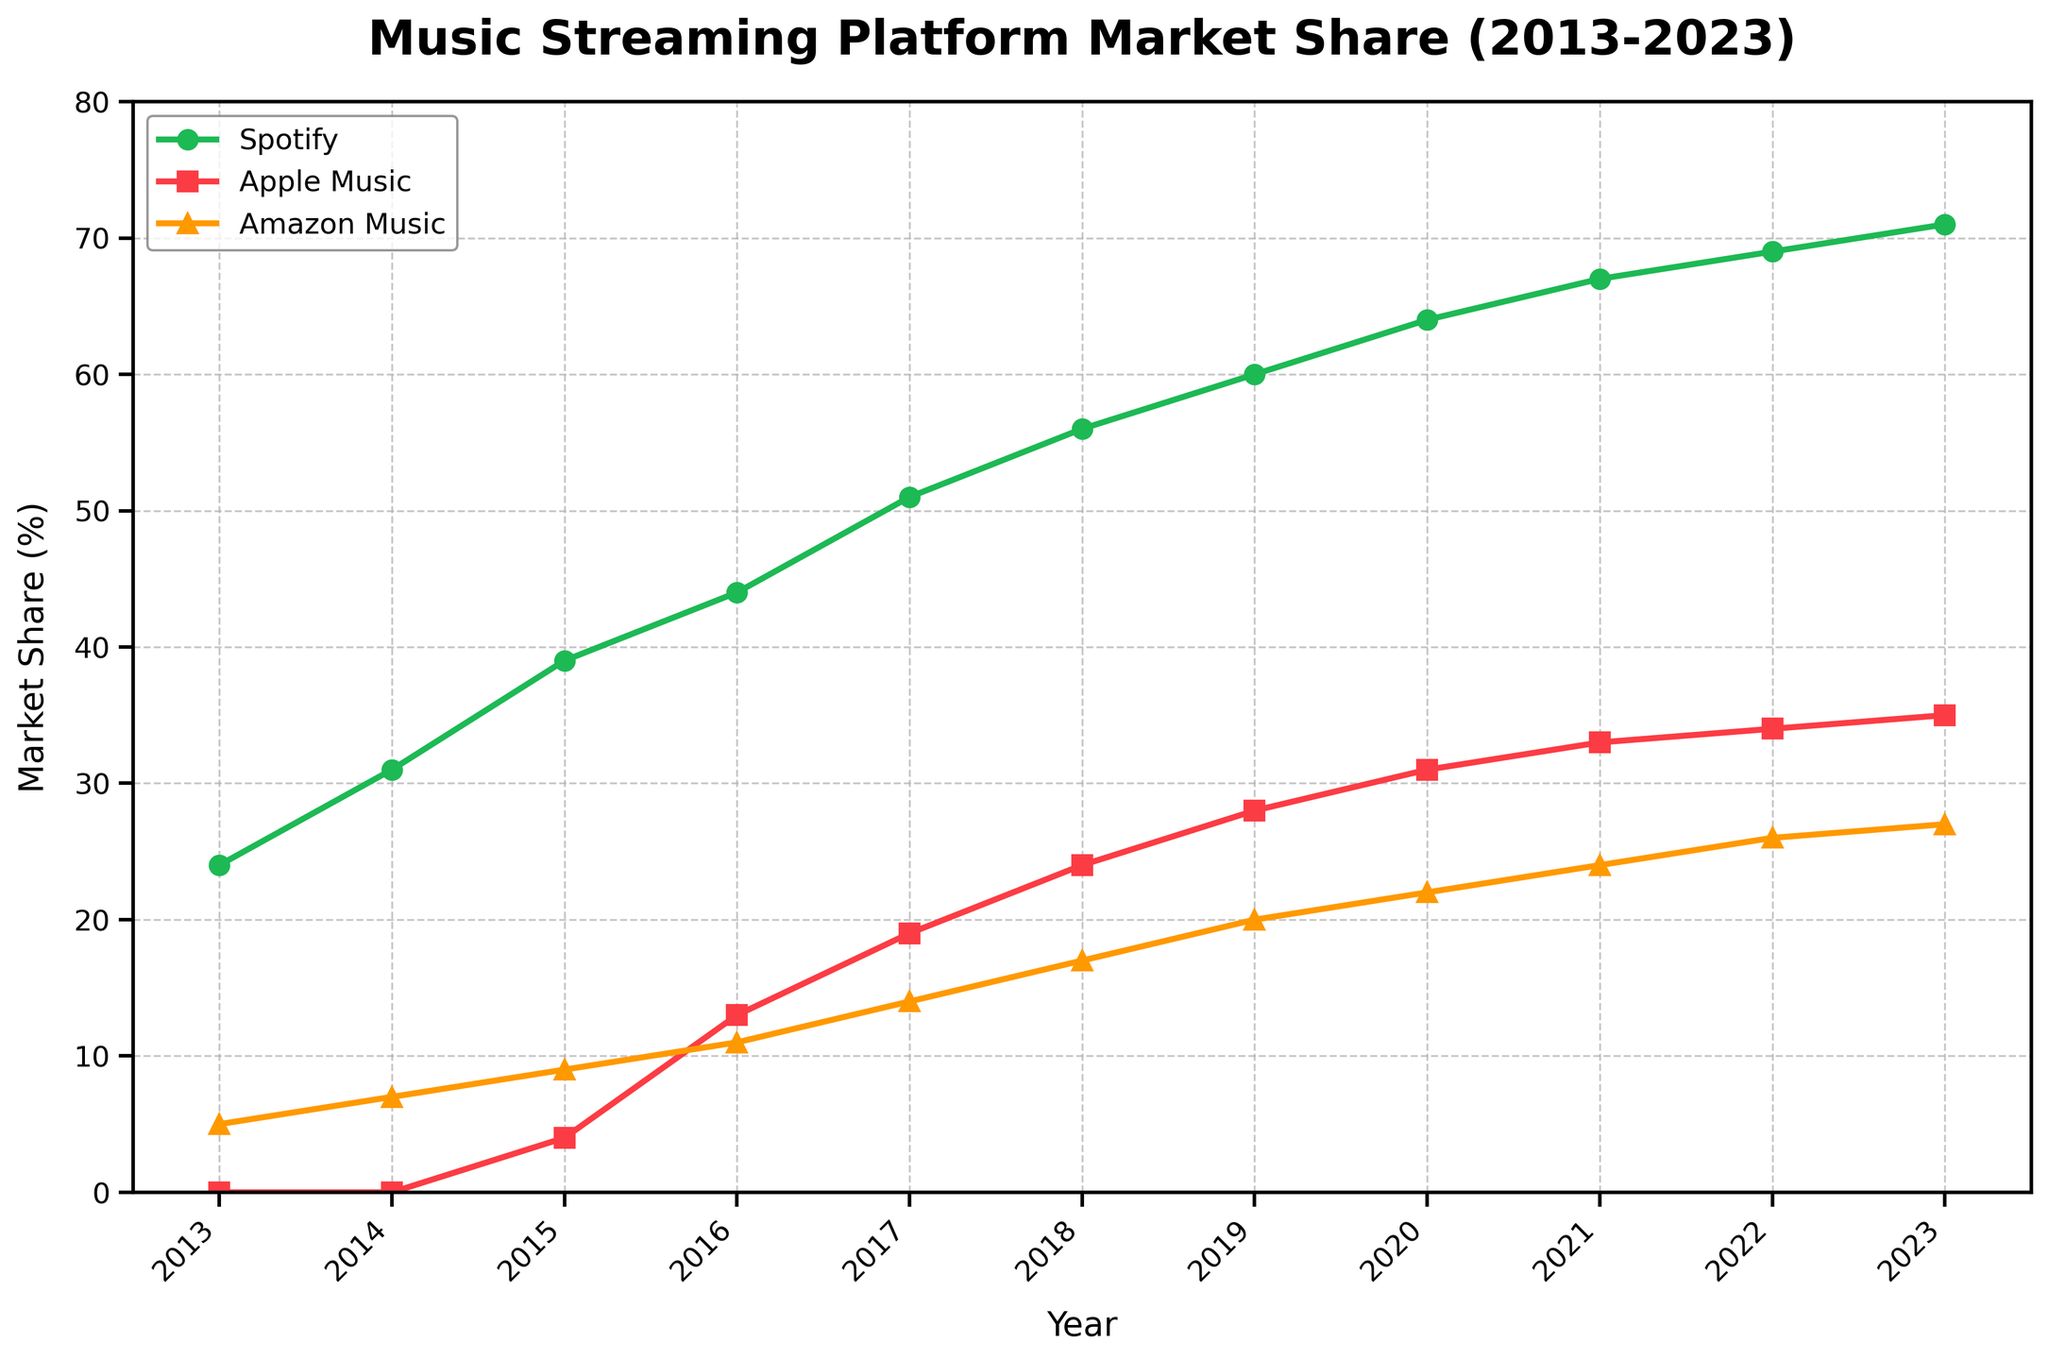What year did Spotify first exceed 50% market share? Look for the year where Spotify's market share first goes above 50%. According to the figure, this occurs in 2017.
Answer: 2017 Which platform had the highest growth in market share between 2016 and 2023? Calculate the market share growth for each platform from 2016 to 2023 and compare them. Spotify grew from 44% to 71% (27%), Apple Music from 13% to 35% (22%), and Amazon Music from 11% to 27% (16%). Spotify had the highest growth.
Answer: Spotify In what year did Apple Music first reach a market share of 30%? Find the year on the x-axis where Apple Music's market share on the y-axis first reaches 30%. The chart shows that this happened in 2020.
Answer: 2020 What is the total market share of all three platforms in 2023? Add up the market shares of Spotify (71%), Apple Music (35%), and Amazon Music (27%) for the year 2023. The total is 71 + 35 + 27 = 133%.
Answer: 133% Which year saw the largest increase in market share for Apple Music compared to the previous year? Calculate the year-over-year differences in market share for Apple Music and identify the year with the largest increase. The differences are 4% (2016), 6% (2017), 5% (2018), 4% (2019), 3% (2020), 2% (2021), 1% (2022), and 1% (2023). The largest increase of 6% occurred in 2017.
Answer: 2017 How much higher was Spotify's market share in 2023 compared to Amazon Music's market share the same year? Subtract Amazon Music's market share in 2023 (27%) from Spotify's market share in 2023 (71%). The difference is 71 - 27 = 44%.
Answer: 44% Did any platform ever surpass Spotify in market share during the decade? Examine the entire chart to see if any platform's line goes above Spotify's line at any point. None of the platforms surpassed Spotify in market share during the decade.
Answer: No What is the average market share of Spotify over the decade? Add up the market share percentages of Spotify for all years (24 + 31 + 39 + 44 + 51 + 56 + 60 + 64 + 67 + 69 + 71) and divide by the number of years (11). The sum is 576, so the average is 576 / 11 ≈ 52.36%.
Answer: 52.36% Which two years showed the same market share for Amazon Music? Look for years where Amazon Music's market share percentages are identical. Amazon Music had a 26% market share in both 2022 and 2023.
Answer: 2022 and 2023 